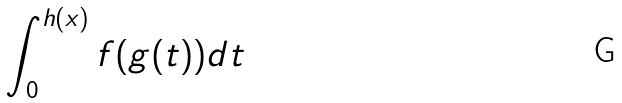<formula> <loc_0><loc_0><loc_500><loc_500>\int _ { 0 } ^ { h ( x ) } f ( g ( t ) ) d t</formula> 